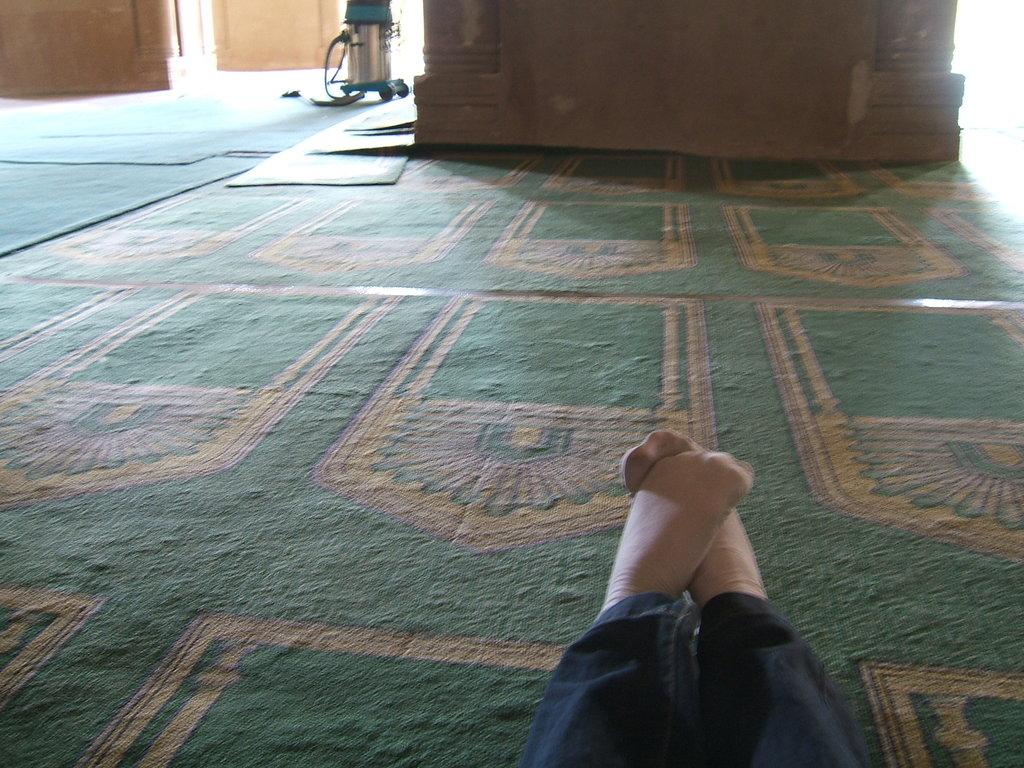What is the person in the foreground of the image wearing? The person in the foreground of the image is wearing black jeans. What can be seen in the background of the image? There are pillars and a device in the background of the image. What is at the bottom of the image? There are mats at the bottom of the image. Can you see a bear sitting on the sofa in the image? There is no bear or sofa present in the image. 